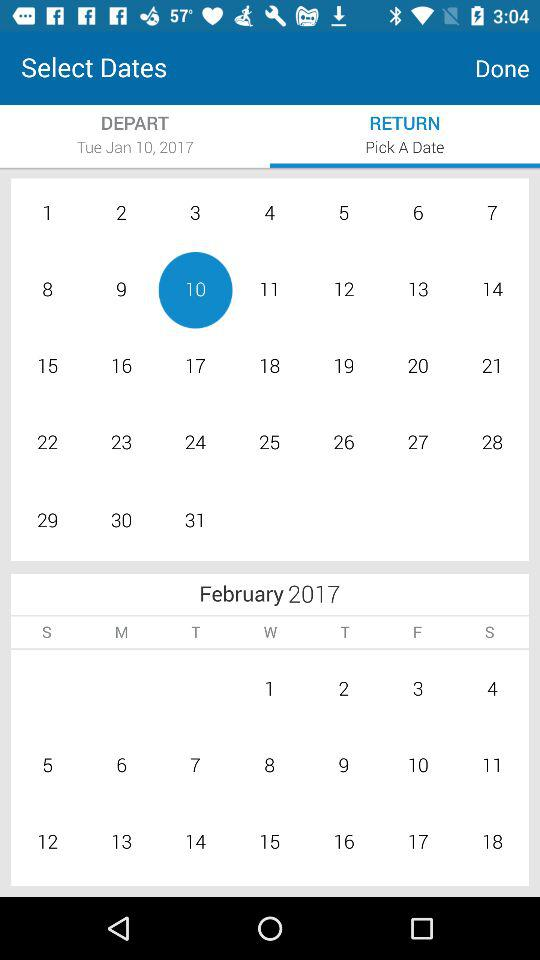What is the departure day and date? The departure day and date are Tuesday and January 10, 2017, respectively. 